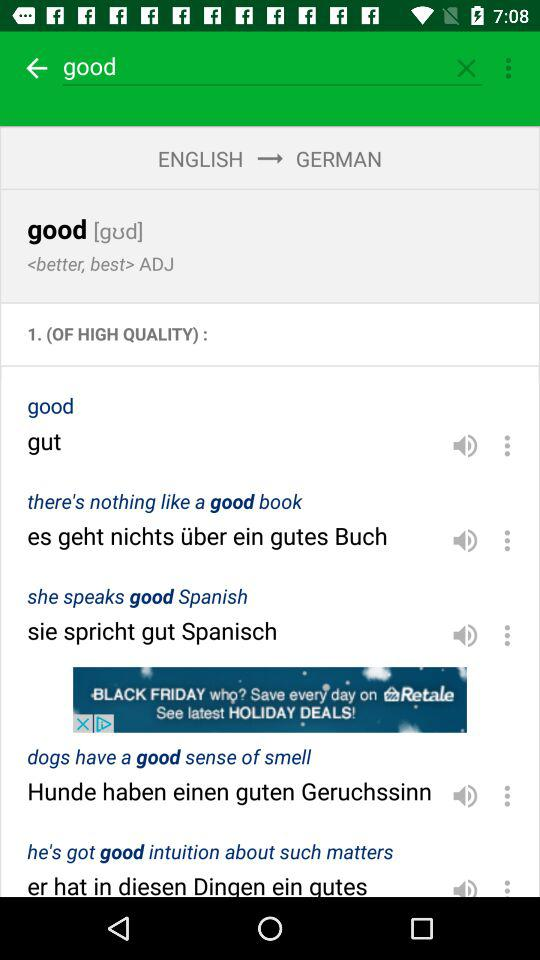How many examples are there in total?
When the provided information is insufficient, respond with <no answer>. <no answer> 